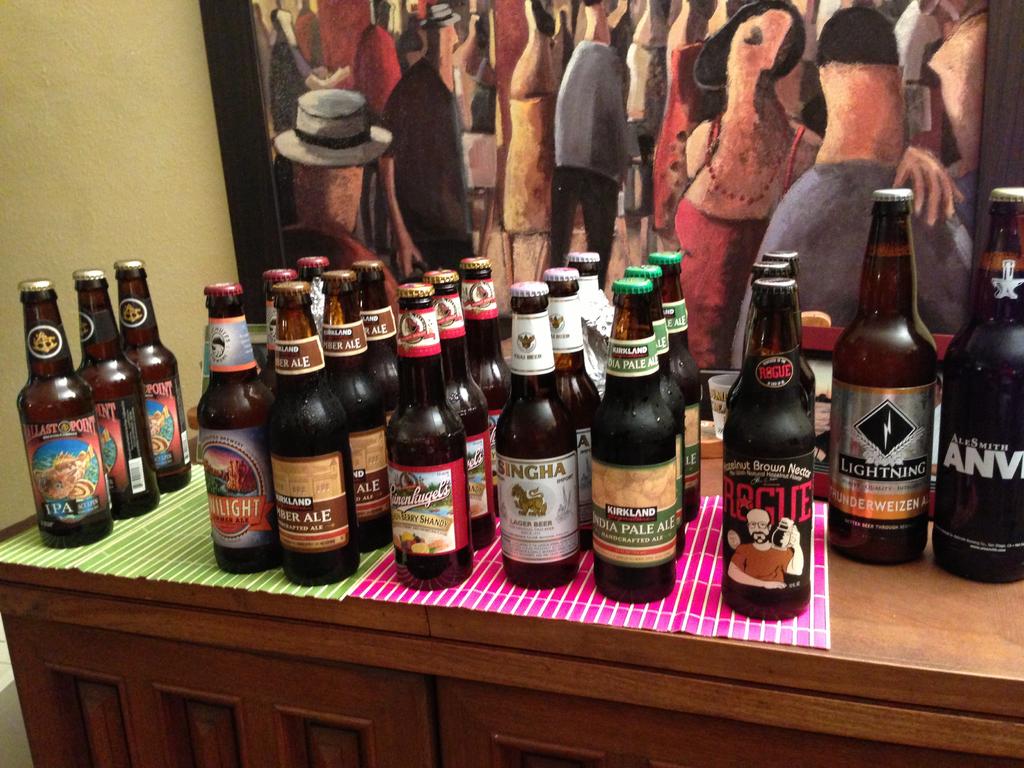What's the brand of beer on the far right?
Make the answer very short. Alesmith. What is the brand of the left beer?
Provide a succinct answer. Ballast point. 